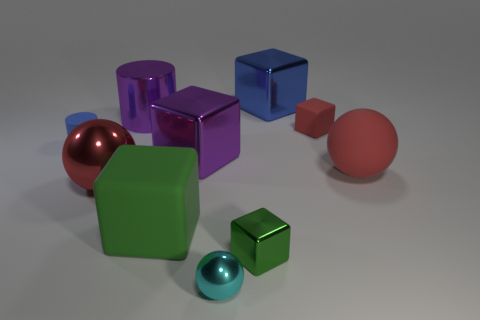There is a purple metal object that is the same shape as the tiny green thing; what is its size?
Keep it short and to the point. Large. The big matte thing that is the same shape as the small green thing is what color?
Your answer should be compact. Green. What number of tiny cyan objects have the same material as the tiny cyan ball?
Give a very brief answer. 0. Is the size of the matte block behind the purple block the same as the big green thing?
Provide a succinct answer. No. What is the color of the rubber thing that is the same size as the green matte block?
Your answer should be compact. Red. How many small blocks are to the right of the small metal block?
Offer a very short reply. 1. Are any small cyan shiny spheres visible?
Make the answer very short. Yes. What size is the cylinder on the right side of the blue thing that is in front of the matte block that is behind the big green rubber object?
Provide a short and direct response. Large. How many other things are there of the same size as the red shiny thing?
Offer a terse response. 5. How big is the red rubber object that is behind the large matte sphere?
Provide a short and direct response. Small. 